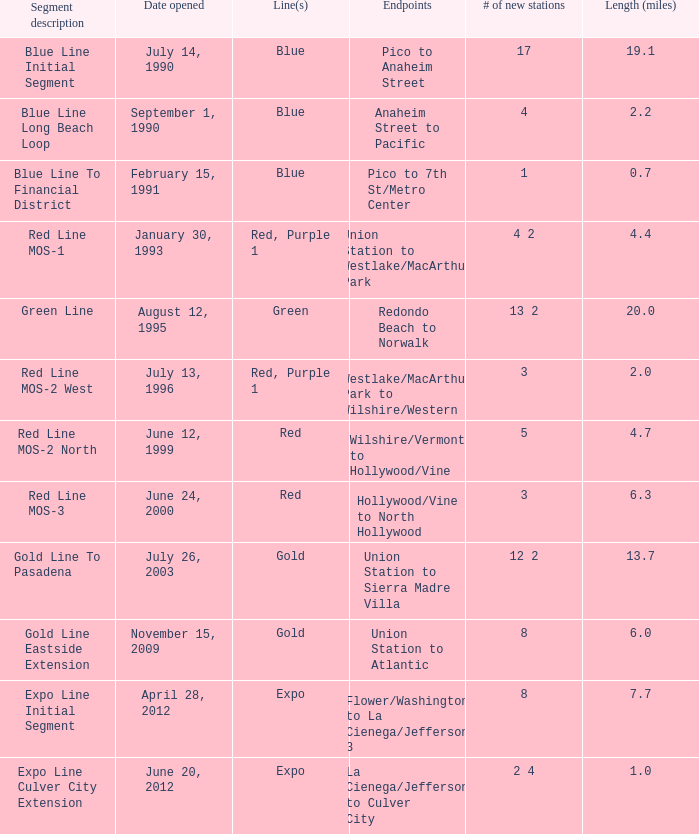How many new stations possess a length (miles) of 1.0. 